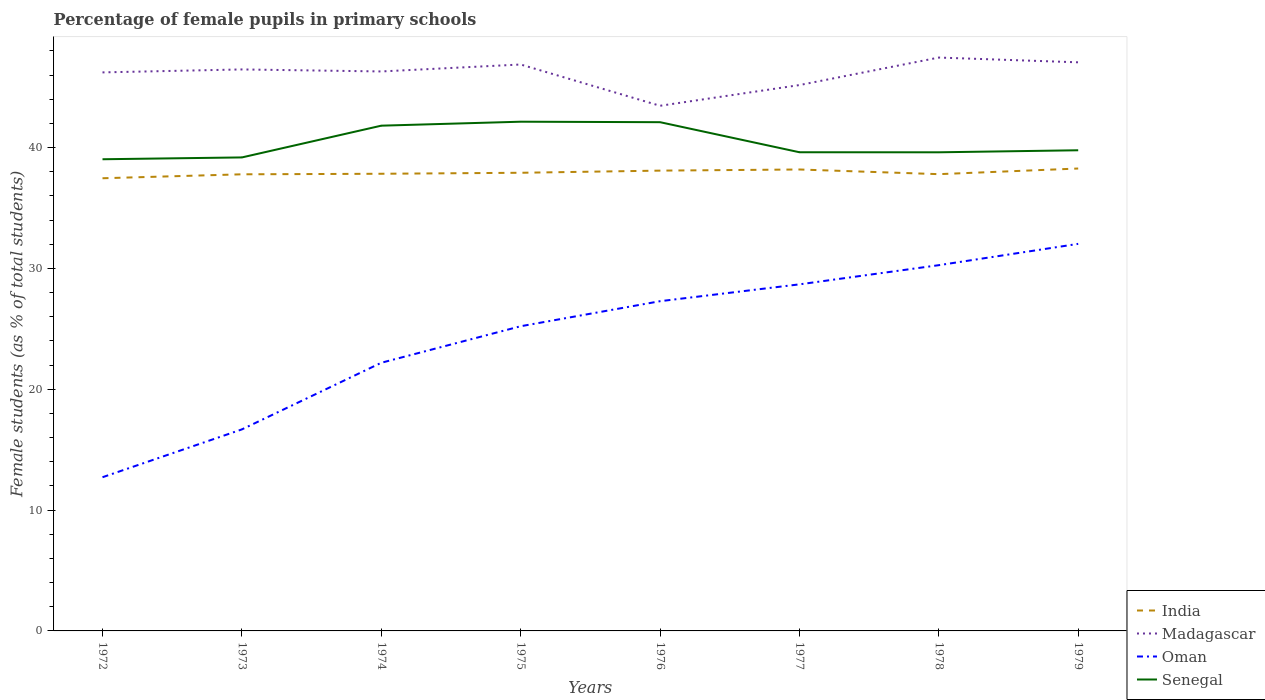Does the line corresponding to India intersect with the line corresponding to Oman?
Your answer should be compact. No. Is the number of lines equal to the number of legend labels?
Ensure brevity in your answer.  Yes. Across all years, what is the maximum percentage of female pupils in primary schools in Madagascar?
Give a very brief answer. 43.46. In which year was the percentage of female pupils in primary schools in Madagascar maximum?
Make the answer very short. 1976. What is the total percentage of female pupils in primary schools in Oman in the graph?
Your answer should be very brief. -2.07. What is the difference between the highest and the second highest percentage of female pupils in primary schools in Senegal?
Offer a terse response. 3.11. What is the difference between two consecutive major ticks on the Y-axis?
Give a very brief answer. 10. Are the values on the major ticks of Y-axis written in scientific E-notation?
Keep it short and to the point. No. Does the graph contain any zero values?
Your response must be concise. No. Where does the legend appear in the graph?
Provide a succinct answer. Bottom right. How many legend labels are there?
Make the answer very short. 4. What is the title of the graph?
Your answer should be compact. Percentage of female pupils in primary schools. What is the label or title of the Y-axis?
Offer a very short reply. Female students (as % of total students). What is the Female students (as % of total students) of India in 1972?
Offer a terse response. 37.46. What is the Female students (as % of total students) in Madagascar in 1972?
Offer a very short reply. 46.22. What is the Female students (as % of total students) in Oman in 1972?
Ensure brevity in your answer.  12.72. What is the Female students (as % of total students) in Senegal in 1972?
Keep it short and to the point. 39.03. What is the Female students (as % of total students) of India in 1973?
Offer a terse response. 37.79. What is the Female students (as % of total students) in Madagascar in 1973?
Ensure brevity in your answer.  46.47. What is the Female students (as % of total students) of Oman in 1973?
Provide a succinct answer. 16.68. What is the Female students (as % of total students) in Senegal in 1973?
Keep it short and to the point. 39.18. What is the Female students (as % of total students) of India in 1974?
Make the answer very short. 37.83. What is the Female students (as % of total students) in Madagascar in 1974?
Ensure brevity in your answer.  46.3. What is the Female students (as % of total students) of Oman in 1974?
Your answer should be very brief. 22.19. What is the Female students (as % of total students) of Senegal in 1974?
Your response must be concise. 41.81. What is the Female students (as % of total students) in India in 1975?
Your answer should be compact. 37.91. What is the Female students (as % of total students) in Madagascar in 1975?
Your answer should be compact. 46.87. What is the Female students (as % of total students) of Oman in 1975?
Provide a short and direct response. 25.21. What is the Female students (as % of total students) of Senegal in 1975?
Provide a succinct answer. 42.14. What is the Female students (as % of total students) in India in 1976?
Your response must be concise. 38.09. What is the Female students (as % of total students) in Madagascar in 1976?
Give a very brief answer. 43.46. What is the Female students (as % of total students) in Oman in 1976?
Your answer should be compact. 27.29. What is the Female students (as % of total students) in Senegal in 1976?
Your answer should be very brief. 42.1. What is the Female students (as % of total students) of India in 1977?
Provide a short and direct response. 38.18. What is the Female students (as % of total students) of Madagascar in 1977?
Provide a short and direct response. 45.17. What is the Female students (as % of total students) in Oman in 1977?
Keep it short and to the point. 28.68. What is the Female students (as % of total students) of Senegal in 1977?
Provide a succinct answer. 39.61. What is the Female students (as % of total students) of India in 1978?
Offer a very short reply. 37.8. What is the Female students (as % of total students) in Madagascar in 1978?
Offer a terse response. 47.45. What is the Female students (as % of total students) of Oman in 1978?
Ensure brevity in your answer.  30.27. What is the Female students (as % of total students) in Senegal in 1978?
Ensure brevity in your answer.  39.61. What is the Female students (as % of total students) in India in 1979?
Provide a succinct answer. 38.27. What is the Female students (as % of total students) in Madagascar in 1979?
Provide a succinct answer. 47.05. What is the Female students (as % of total students) in Oman in 1979?
Your answer should be compact. 32.03. What is the Female students (as % of total students) of Senegal in 1979?
Make the answer very short. 39.78. Across all years, what is the maximum Female students (as % of total students) in India?
Ensure brevity in your answer.  38.27. Across all years, what is the maximum Female students (as % of total students) of Madagascar?
Ensure brevity in your answer.  47.45. Across all years, what is the maximum Female students (as % of total students) in Oman?
Give a very brief answer. 32.03. Across all years, what is the maximum Female students (as % of total students) of Senegal?
Ensure brevity in your answer.  42.14. Across all years, what is the minimum Female students (as % of total students) of India?
Make the answer very short. 37.46. Across all years, what is the minimum Female students (as % of total students) of Madagascar?
Keep it short and to the point. 43.46. Across all years, what is the minimum Female students (as % of total students) of Oman?
Provide a succinct answer. 12.72. Across all years, what is the minimum Female students (as % of total students) of Senegal?
Give a very brief answer. 39.03. What is the total Female students (as % of total students) in India in the graph?
Make the answer very short. 303.33. What is the total Female students (as % of total students) in Madagascar in the graph?
Your answer should be very brief. 368.99. What is the total Female students (as % of total students) in Oman in the graph?
Offer a terse response. 195.06. What is the total Female students (as % of total students) in Senegal in the graph?
Your response must be concise. 323.26. What is the difference between the Female students (as % of total students) in India in 1972 and that in 1973?
Keep it short and to the point. -0.33. What is the difference between the Female students (as % of total students) of Madagascar in 1972 and that in 1973?
Your answer should be compact. -0.24. What is the difference between the Female students (as % of total students) in Oman in 1972 and that in 1973?
Provide a succinct answer. -3.96. What is the difference between the Female students (as % of total students) in Senegal in 1972 and that in 1973?
Your response must be concise. -0.15. What is the difference between the Female students (as % of total students) of India in 1972 and that in 1974?
Ensure brevity in your answer.  -0.37. What is the difference between the Female students (as % of total students) of Madagascar in 1972 and that in 1974?
Provide a succinct answer. -0.08. What is the difference between the Female students (as % of total students) of Oman in 1972 and that in 1974?
Offer a terse response. -9.47. What is the difference between the Female students (as % of total students) in Senegal in 1972 and that in 1974?
Keep it short and to the point. -2.78. What is the difference between the Female students (as % of total students) in India in 1972 and that in 1975?
Keep it short and to the point. -0.45. What is the difference between the Female students (as % of total students) of Madagascar in 1972 and that in 1975?
Offer a very short reply. -0.65. What is the difference between the Female students (as % of total students) of Oman in 1972 and that in 1975?
Make the answer very short. -12.49. What is the difference between the Female students (as % of total students) of Senegal in 1972 and that in 1975?
Offer a terse response. -3.11. What is the difference between the Female students (as % of total students) in India in 1972 and that in 1976?
Make the answer very short. -0.63. What is the difference between the Female students (as % of total students) in Madagascar in 1972 and that in 1976?
Provide a succinct answer. 2.76. What is the difference between the Female students (as % of total students) of Oman in 1972 and that in 1976?
Provide a succinct answer. -14.57. What is the difference between the Female students (as % of total students) of Senegal in 1972 and that in 1976?
Provide a short and direct response. -3.07. What is the difference between the Female students (as % of total students) in India in 1972 and that in 1977?
Your answer should be compact. -0.72. What is the difference between the Female students (as % of total students) in Madagascar in 1972 and that in 1977?
Ensure brevity in your answer.  1.05. What is the difference between the Female students (as % of total students) of Oman in 1972 and that in 1977?
Offer a terse response. -15.96. What is the difference between the Female students (as % of total students) in Senegal in 1972 and that in 1977?
Make the answer very short. -0.58. What is the difference between the Female students (as % of total students) in India in 1972 and that in 1978?
Give a very brief answer. -0.34. What is the difference between the Female students (as % of total students) in Madagascar in 1972 and that in 1978?
Make the answer very short. -1.23. What is the difference between the Female students (as % of total students) in Oman in 1972 and that in 1978?
Provide a succinct answer. -17.55. What is the difference between the Female students (as % of total students) in Senegal in 1972 and that in 1978?
Ensure brevity in your answer.  -0.58. What is the difference between the Female students (as % of total students) in India in 1972 and that in 1979?
Your answer should be compact. -0.81. What is the difference between the Female students (as % of total students) of Madagascar in 1972 and that in 1979?
Provide a succinct answer. -0.83. What is the difference between the Female students (as % of total students) of Oman in 1972 and that in 1979?
Your response must be concise. -19.31. What is the difference between the Female students (as % of total students) of Senegal in 1972 and that in 1979?
Give a very brief answer. -0.74. What is the difference between the Female students (as % of total students) of India in 1973 and that in 1974?
Make the answer very short. -0.04. What is the difference between the Female students (as % of total students) in Madagascar in 1973 and that in 1974?
Give a very brief answer. 0.17. What is the difference between the Female students (as % of total students) of Oman in 1973 and that in 1974?
Provide a succinct answer. -5.51. What is the difference between the Female students (as % of total students) in Senegal in 1973 and that in 1974?
Your answer should be compact. -2.63. What is the difference between the Female students (as % of total students) in India in 1973 and that in 1975?
Offer a terse response. -0.13. What is the difference between the Female students (as % of total students) in Madagascar in 1973 and that in 1975?
Keep it short and to the point. -0.41. What is the difference between the Female students (as % of total students) of Oman in 1973 and that in 1975?
Make the answer very short. -8.54. What is the difference between the Female students (as % of total students) in Senegal in 1973 and that in 1975?
Offer a terse response. -2.96. What is the difference between the Female students (as % of total students) in India in 1973 and that in 1976?
Make the answer very short. -0.31. What is the difference between the Female students (as % of total students) in Madagascar in 1973 and that in 1976?
Keep it short and to the point. 3.01. What is the difference between the Female students (as % of total students) in Oman in 1973 and that in 1976?
Offer a terse response. -10.61. What is the difference between the Female students (as % of total students) of Senegal in 1973 and that in 1976?
Provide a short and direct response. -2.92. What is the difference between the Female students (as % of total students) in India in 1973 and that in 1977?
Offer a very short reply. -0.4. What is the difference between the Female students (as % of total students) in Madagascar in 1973 and that in 1977?
Provide a succinct answer. 1.29. What is the difference between the Female students (as % of total students) of Oman in 1973 and that in 1977?
Your answer should be compact. -12. What is the difference between the Female students (as % of total students) in Senegal in 1973 and that in 1977?
Your answer should be very brief. -0.43. What is the difference between the Female students (as % of total students) of India in 1973 and that in 1978?
Offer a very short reply. -0.01. What is the difference between the Female students (as % of total students) in Madagascar in 1973 and that in 1978?
Your response must be concise. -0.98. What is the difference between the Female students (as % of total students) in Oman in 1973 and that in 1978?
Offer a terse response. -13.59. What is the difference between the Female students (as % of total students) of Senegal in 1973 and that in 1978?
Give a very brief answer. -0.42. What is the difference between the Female students (as % of total students) in India in 1973 and that in 1979?
Provide a short and direct response. -0.48. What is the difference between the Female students (as % of total students) of Madagascar in 1973 and that in 1979?
Your response must be concise. -0.59. What is the difference between the Female students (as % of total students) in Oman in 1973 and that in 1979?
Offer a terse response. -15.35. What is the difference between the Female students (as % of total students) in Senegal in 1973 and that in 1979?
Provide a short and direct response. -0.59. What is the difference between the Female students (as % of total students) of India in 1974 and that in 1975?
Offer a terse response. -0.08. What is the difference between the Female students (as % of total students) in Madagascar in 1974 and that in 1975?
Give a very brief answer. -0.58. What is the difference between the Female students (as % of total students) of Oman in 1974 and that in 1975?
Give a very brief answer. -3.02. What is the difference between the Female students (as % of total students) in Senegal in 1974 and that in 1975?
Offer a very short reply. -0.33. What is the difference between the Female students (as % of total students) of India in 1974 and that in 1976?
Give a very brief answer. -0.26. What is the difference between the Female students (as % of total students) of Madagascar in 1974 and that in 1976?
Your answer should be very brief. 2.84. What is the difference between the Female students (as % of total students) of Oman in 1974 and that in 1976?
Keep it short and to the point. -5.1. What is the difference between the Female students (as % of total students) in Senegal in 1974 and that in 1976?
Provide a succinct answer. -0.29. What is the difference between the Female students (as % of total students) of India in 1974 and that in 1977?
Your answer should be compact. -0.35. What is the difference between the Female students (as % of total students) of Madagascar in 1974 and that in 1977?
Make the answer very short. 1.13. What is the difference between the Female students (as % of total students) in Oman in 1974 and that in 1977?
Keep it short and to the point. -6.49. What is the difference between the Female students (as % of total students) in Senegal in 1974 and that in 1977?
Offer a very short reply. 2.2. What is the difference between the Female students (as % of total students) of India in 1974 and that in 1978?
Your answer should be compact. 0.03. What is the difference between the Female students (as % of total students) in Madagascar in 1974 and that in 1978?
Provide a short and direct response. -1.15. What is the difference between the Female students (as % of total students) in Oman in 1974 and that in 1978?
Keep it short and to the point. -8.08. What is the difference between the Female students (as % of total students) of Senegal in 1974 and that in 1978?
Provide a succinct answer. 2.2. What is the difference between the Female students (as % of total students) in India in 1974 and that in 1979?
Make the answer very short. -0.43. What is the difference between the Female students (as % of total students) in Madagascar in 1974 and that in 1979?
Offer a terse response. -0.76. What is the difference between the Female students (as % of total students) of Oman in 1974 and that in 1979?
Provide a short and direct response. -9.84. What is the difference between the Female students (as % of total students) in Senegal in 1974 and that in 1979?
Provide a succinct answer. 2.03. What is the difference between the Female students (as % of total students) of India in 1975 and that in 1976?
Your answer should be compact. -0.18. What is the difference between the Female students (as % of total students) in Madagascar in 1975 and that in 1976?
Offer a terse response. 3.42. What is the difference between the Female students (as % of total students) in Oman in 1975 and that in 1976?
Your answer should be very brief. -2.07. What is the difference between the Female students (as % of total students) in Senegal in 1975 and that in 1976?
Offer a very short reply. 0.04. What is the difference between the Female students (as % of total students) in India in 1975 and that in 1977?
Make the answer very short. -0.27. What is the difference between the Female students (as % of total students) in Madagascar in 1975 and that in 1977?
Keep it short and to the point. 1.7. What is the difference between the Female students (as % of total students) of Oman in 1975 and that in 1977?
Make the answer very short. -3.47. What is the difference between the Female students (as % of total students) in Senegal in 1975 and that in 1977?
Provide a short and direct response. 2.53. What is the difference between the Female students (as % of total students) of India in 1975 and that in 1978?
Give a very brief answer. 0.11. What is the difference between the Female students (as % of total students) of Madagascar in 1975 and that in 1978?
Keep it short and to the point. -0.57. What is the difference between the Female students (as % of total students) of Oman in 1975 and that in 1978?
Provide a succinct answer. -5.05. What is the difference between the Female students (as % of total students) in Senegal in 1975 and that in 1978?
Offer a terse response. 2.53. What is the difference between the Female students (as % of total students) in India in 1975 and that in 1979?
Ensure brevity in your answer.  -0.35. What is the difference between the Female students (as % of total students) of Madagascar in 1975 and that in 1979?
Ensure brevity in your answer.  -0.18. What is the difference between the Female students (as % of total students) in Oman in 1975 and that in 1979?
Give a very brief answer. -6.82. What is the difference between the Female students (as % of total students) in Senegal in 1975 and that in 1979?
Ensure brevity in your answer.  2.36. What is the difference between the Female students (as % of total students) in India in 1976 and that in 1977?
Offer a very short reply. -0.09. What is the difference between the Female students (as % of total students) in Madagascar in 1976 and that in 1977?
Give a very brief answer. -1.71. What is the difference between the Female students (as % of total students) in Oman in 1976 and that in 1977?
Offer a very short reply. -1.39. What is the difference between the Female students (as % of total students) in Senegal in 1976 and that in 1977?
Your answer should be very brief. 2.49. What is the difference between the Female students (as % of total students) in India in 1976 and that in 1978?
Give a very brief answer. 0.29. What is the difference between the Female students (as % of total students) in Madagascar in 1976 and that in 1978?
Provide a short and direct response. -3.99. What is the difference between the Female students (as % of total students) in Oman in 1976 and that in 1978?
Make the answer very short. -2.98. What is the difference between the Female students (as % of total students) in Senegal in 1976 and that in 1978?
Ensure brevity in your answer.  2.49. What is the difference between the Female students (as % of total students) of India in 1976 and that in 1979?
Ensure brevity in your answer.  -0.17. What is the difference between the Female students (as % of total students) of Madagascar in 1976 and that in 1979?
Your answer should be compact. -3.6. What is the difference between the Female students (as % of total students) of Oman in 1976 and that in 1979?
Your response must be concise. -4.74. What is the difference between the Female students (as % of total students) of Senegal in 1976 and that in 1979?
Your answer should be very brief. 2.32. What is the difference between the Female students (as % of total students) in India in 1977 and that in 1978?
Your answer should be compact. 0.39. What is the difference between the Female students (as % of total students) of Madagascar in 1977 and that in 1978?
Your answer should be compact. -2.28. What is the difference between the Female students (as % of total students) in Oman in 1977 and that in 1978?
Offer a terse response. -1.59. What is the difference between the Female students (as % of total students) in Senegal in 1977 and that in 1978?
Your response must be concise. 0. What is the difference between the Female students (as % of total students) in India in 1977 and that in 1979?
Ensure brevity in your answer.  -0.08. What is the difference between the Female students (as % of total students) in Madagascar in 1977 and that in 1979?
Provide a succinct answer. -1.88. What is the difference between the Female students (as % of total students) of Oman in 1977 and that in 1979?
Ensure brevity in your answer.  -3.35. What is the difference between the Female students (as % of total students) in Senegal in 1977 and that in 1979?
Provide a succinct answer. -0.16. What is the difference between the Female students (as % of total students) in India in 1978 and that in 1979?
Your response must be concise. -0.47. What is the difference between the Female students (as % of total students) in Madagascar in 1978 and that in 1979?
Provide a succinct answer. 0.39. What is the difference between the Female students (as % of total students) in Oman in 1978 and that in 1979?
Offer a very short reply. -1.76. What is the difference between the Female students (as % of total students) of Senegal in 1978 and that in 1979?
Offer a very short reply. -0.17. What is the difference between the Female students (as % of total students) in India in 1972 and the Female students (as % of total students) in Madagascar in 1973?
Your answer should be compact. -9. What is the difference between the Female students (as % of total students) of India in 1972 and the Female students (as % of total students) of Oman in 1973?
Give a very brief answer. 20.78. What is the difference between the Female students (as % of total students) of India in 1972 and the Female students (as % of total students) of Senegal in 1973?
Your answer should be very brief. -1.72. What is the difference between the Female students (as % of total students) of Madagascar in 1972 and the Female students (as % of total students) of Oman in 1973?
Provide a succinct answer. 29.54. What is the difference between the Female students (as % of total students) in Madagascar in 1972 and the Female students (as % of total students) in Senegal in 1973?
Make the answer very short. 7.04. What is the difference between the Female students (as % of total students) in Oman in 1972 and the Female students (as % of total students) in Senegal in 1973?
Keep it short and to the point. -26.46. What is the difference between the Female students (as % of total students) of India in 1972 and the Female students (as % of total students) of Madagascar in 1974?
Your response must be concise. -8.84. What is the difference between the Female students (as % of total students) of India in 1972 and the Female students (as % of total students) of Oman in 1974?
Ensure brevity in your answer.  15.27. What is the difference between the Female students (as % of total students) in India in 1972 and the Female students (as % of total students) in Senegal in 1974?
Give a very brief answer. -4.35. What is the difference between the Female students (as % of total students) of Madagascar in 1972 and the Female students (as % of total students) of Oman in 1974?
Provide a short and direct response. 24.03. What is the difference between the Female students (as % of total students) of Madagascar in 1972 and the Female students (as % of total students) of Senegal in 1974?
Make the answer very short. 4.41. What is the difference between the Female students (as % of total students) of Oman in 1972 and the Female students (as % of total students) of Senegal in 1974?
Your response must be concise. -29.09. What is the difference between the Female students (as % of total students) of India in 1972 and the Female students (as % of total students) of Madagascar in 1975?
Provide a succinct answer. -9.41. What is the difference between the Female students (as % of total students) in India in 1972 and the Female students (as % of total students) in Oman in 1975?
Provide a short and direct response. 12.25. What is the difference between the Female students (as % of total students) of India in 1972 and the Female students (as % of total students) of Senegal in 1975?
Keep it short and to the point. -4.68. What is the difference between the Female students (as % of total students) of Madagascar in 1972 and the Female students (as % of total students) of Oman in 1975?
Make the answer very short. 21.01. What is the difference between the Female students (as % of total students) of Madagascar in 1972 and the Female students (as % of total students) of Senegal in 1975?
Make the answer very short. 4.08. What is the difference between the Female students (as % of total students) of Oman in 1972 and the Female students (as % of total students) of Senegal in 1975?
Offer a very short reply. -29.42. What is the difference between the Female students (as % of total students) of India in 1972 and the Female students (as % of total students) of Madagascar in 1976?
Ensure brevity in your answer.  -6. What is the difference between the Female students (as % of total students) of India in 1972 and the Female students (as % of total students) of Oman in 1976?
Give a very brief answer. 10.17. What is the difference between the Female students (as % of total students) of India in 1972 and the Female students (as % of total students) of Senegal in 1976?
Ensure brevity in your answer.  -4.64. What is the difference between the Female students (as % of total students) of Madagascar in 1972 and the Female students (as % of total students) of Oman in 1976?
Provide a short and direct response. 18.94. What is the difference between the Female students (as % of total students) of Madagascar in 1972 and the Female students (as % of total students) of Senegal in 1976?
Provide a short and direct response. 4.12. What is the difference between the Female students (as % of total students) of Oman in 1972 and the Female students (as % of total students) of Senegal in 1976?
Make the answer very short. -29.38. What is the difference between the Female students (as % of total students) in India in 1972 and the Female students (as % of total students) in Madagascar in 1977?
Your response must be concise. -7.71. What is the difference between the Female students (as % of total students) in India in 1972 and the Female students (as % of total students) in Oman in 1977?
Provide a succinct answer. 8.78. What is the difference between the Female students (as % of total students) of India in 1972 and the Female students (as % of total students) of Senegal in 1977?
Provide a succinct answer. -2.15. What is the difference between the Female students (as % of total students) of Madagascar in 1972 and the Female students (as % of total students) of Oman in 1977?
Offer a terse response. 17.54. What is the difference between the Female students (as % of total students) of Madagascar in 1972 and the Female students (as % of total students) of Senegal in 1977?
Keep it short and to the point. 6.61. What is the difference between the Female students (as % of total students) of Oman in 1972 and the Female students (as % of total students) of Senegal in 1977?
Your answer should be very brief. -26.89. What is the difference between the Female students (as % of total students) in India in 1972 and the Female students (as % of total students) in Madagascar in 1978?
Provide a succinct answer. -9.99. What is the difference between the Female students (as % of total students) of India in 1972 and the Female students (as % of total students) of Oman in 1978?
Ensure brevity in your answer.  7.19. What is the difference between the Female students (as % of total students) of India in 1972 and the Female students (as % of total students) of Senegal in 1978?
Provide a succinct answer. -2.15. What is the difference between the Female students (as % of total students) of Madagascar in 1972 and the Female students (as % of total students) of Oman in 1978?
Ensure brevity in your answer.  15.95. What is the difference between the Female students (as % of total students) in Madagascar in 1972 and the Female students (as % of total students) in Senegal in 1978?
Ensure brevity in your answer.  6.61. What is the difference between the Female students (as % of total students) in Oman in 1972 and the Female students (as % of total students) in Senegal in 1978?
Provide a succinct answer. -26.89. What is the difference between the Female students (as % of total students) of India in 1972 and the Female students (as % of total students) of Madagascar in 1979?
Your response must be concise. -9.59. What is the difference between the Female students (as % of total students) in India in 1972 and the Female students (as % of total students) in Oman in 1979?
Offer a terse response. 5.43. What is the difference between the Female students (as % of total students) of India in 1972 and the Female students (as % of total students) of Senegal in 1979?
Offer a terse response. -2.32. What is the difference between the Female students (as % of total students) in Madagascar in 1972 and the Female students (as % of total students) in Oman in 1979?
Make the answer very short. 14.19. What is the difference between the Female students (as % of total students) in Madagascar in 1972 and the Female students (as % of total students) in Senegal in 1979?
Your answer should be compact. 6.44. What is the difference between the Female students (as % of total students) in Oman in 1972 and the Female students (as % of total students) in Senegal in 1979?
Ensure brevity in your answer.  -27.06. What is the difference between the Female students (as % of total students) in India in 1973 and the Female students (as % of total students) in Madagascar in 1974?
Keep it short and to the point. -8.51. What is the difference between the Female students (as % of total students) in India in 1973 and the Female students (as % of total students) in Oman in 1974?
Your answer should be very brief. 15.6. What is the difference between the Female students (as % of total students) of India in 1973 and the Female students (as % of total students) of Senegal in 1974?
Your answer should be compact. -4.02. What is the difference between the Female students (as % of total students) in Madagascar in 1973 and the Female students (as % of total students) in Oman in 1974?
Offer a very short reply. 24.27. What is the difference between the Female students (as % of total students) in Madagascar in 1973 and the Female students (as % of total students) in Senegal in 1974?
Give a very brief answer. 4.65. What is the difference between the Female students (as % of total students) in Oman in 1973 and the Female students (as % of total students) in Senegal in 1974?
Ensure brevity in your answer.  -25.13. What is the difference between the Female students (as % of total students) of India in 1973 and the Female students (as % of total students) of Madagascar in 1975?
Ensure brevity in your answer.  -9.09. What is the difference between the Female students (as % of total students) of India in 1973 and the Female students (as % of total students) of Oman in 1975?
Your answer should be compact. 12.57. What is the difference between the Female students (as % of total students) in India in 1973 and the Female students (as % of total students) in Senegal in 1975?
Your answer should be very brief. -4.35. What is the difference between the Female students (as % of total students) in Madagascar in 1973 and the Female students (as % of total students) in Oman in 1975?
Make the answer very short. 21.25. What is the difference between the Female students (as % of total students) in Madagascar in 1973 and the Female students (as % of total students) in Senegal in 1975?
Ensure brevity in your answer.  4.33. What is the difference between the Female students (as % of total students) in Oman in 1973 and the Female students (as % of total students) in Senegal in 1975?
Make the answer very short. -25.46. What is the difference between the Female students (as % of total students) in India in 1973 and the Female students (as % of total students) in Madagascar in 1976?
Make the answer very short. -5.67. What is the difference between the Female students (as % of total students) of India in 1973 and the Female students (as % of total students) of Oman in 1976?
Your response must be concise. 10.5. What is the difference between the Female students (as % of total students) in India in 1973 and the Female students (as % of total students) in Senegal in 1976?
Make the answer very short. -4.31. What is the difference between the Female students (as % of total students) in Madagascar in 1973 and the Female students (as % of total students) in Oman in 1976?
Keep it short and to the point. 19.18. What is the difference between the Female students (as % of total students) of Madagascar in 1973 and the Female students (as % of total students) of Senegal in 1976?
Give a very brief answer. 4.37. What is the difference between the Female students (as % of total students) in Oman in 1973 and the Female students (as % of total students) in Senegal in 1976?
Offer a terse response. -25.42. What is the difference between the Female students (as % of total students) of India in 1973 and the Female students (as % of total students) of Madagascar in 1977?
Keep it short and to the point. -7.38. What is the difference between the Female students (as % of total students) of India in 1973 and the Female students (as % of total students) of Oman in 1977?
Offer a very short reply. 9.11. What is the difference between the Female students (as % of total students) of India in 1973 and the Female students (as % of total students) of Senegal in 1977?
Ensure brevity in your answer.  -1.83. What is the difference between the Female students (as % of total students) in Madagascar in 1973 and the Female students (as % of total students) in Oman in 1977?
Provide a short and direct response. 17.79. What is the difference between the Female students (as % of total students) in Madagascar in 1973 and the Female students (as % of total students) in Senegal in 1977?
Provide a succinct answer. 6.85. What is the difference between the Female students (as % of total students) of Oman in 1973 and the Female students (as % of total students) of Senegal in 1977?
Offer a terse response. -22.94. What is the difference between the Female students (as % of total students) in India in 1973 and the Female students (as % of total students) in Madagascar in 1978?
Provide a succinct answer. -9.66. What is the difference between the Female students (as % of total students) in India in 1973 and the Female students (as % of total students) in Oman in 1978?
Your answer should be very brief. 7.52. What is the difference between the Female students (as % of total students) of India in 1973 and the Female students (as % of total students) of Senegal in 1978?
Ensure brevity in your answer.  -1.82. What is the difference between the Female students (as % of total students) of Madagascar in 1973 and the Female students (as % of total students) of Oman in 1978?
Give a very brief answer. 16.2. What is the difference between the Female students (as % of total students) in Madagascar in 1973 and the Female students (as % of total students) in Senegal in 1978?
Your response must be concise. 6.86. What is the difference between the Female students (as % of total students) of Oman in 1973 and the Female students (as % of total students) of Senegal in 1978?
Provide a succinct answer. -22.93. What is the difference between the Female students (as % of total students) of India in 1973 and the Female students (as % of total students) of Madagascar in 1979?
Provide a short and direct response. -9.27. What is the difference between the Female students (as % of total students) in India in 1973 and the Female students (as % of total students) in Oman in 1979?
Your response must be concise. 5.76. What is the difference between the Female students (as % of total students) of India in 1973 and the Female students (as % of total students) of Senegal in 1979?
Offer a very short reply. -1.99. What is the difference between the Female students (as % of total students) in Madagascar in 1973 and the Female students (as % of total students) in Oman in 1979?
Ensure brevity in your answer.  14.44. What is the difference between the Female students (as % of total students) of Madagascar in 1973 and the Female students (as % of total students) of Senegal in 1979?
Make the answer very short. 6.69. What is the difference between the Female students (as % of total students) in Oman in 1973 and the Female students (as % of total students) in Senegal in 1979?
Give a very brief answer. -23.1. What is the difference between the Female students (as % of total students) of India in 1974 and the Female students (as % of total students) of Madagascar in 1975?
Give a very brief answer. -9.04. What is the difference between the Female students (as % of total students) of India in 1974 and the Female students (as % of total students) of Oman in 1975?
Provide a succinct answer. 12.62. What is the difference between the Female students (as % of total students) of India in 1974 and the Female students (as % of total students) of Senegal in 1975?
Give a very brief answer. -4.31. What is the difference between the Female students (as % of total students) in Madagascar in 1974 and the Female students (as % of total students) in Oman in 1975?
Offer a very short reply. 21.08. What is the difference between the Female students (as % of total students) in Madagascar in 1974 and the Female students (as % of total students) in Senegal in 1975?
Provide a succinct answer. 4.16. What is the difference between the Female students (as % of total students) in Oman in 1974 and the Female students (as % of total students) in Senegal in 1975?
Give a very brief answer. -19.95. What is the difference between the Female students (as % of total students) of India in 1974 and the Female students (as % of total students) of Madagascar in 1976?
Give a very brief answer. -5.63. What is the difference between the Female students (as % of total students) of India in 1974 and the Female students (as % of total students) of Oman in 1976?
Provide a succinct answer. 10.55. What is the difference between the Female students (as % of total students) of India in 1974 and the Female students (as % of total students) of Senegal in 1976?
Provide a succinct answer. -4.27. What is the difference between the Female students (as % of total students) in Madagascar in 1974 and the Female students (as % of total students) in Oman in 1976?
Provide a succinct answer. 19.01. What is the difference between the Female students (as % of total students) in Madagascar in 1974 and the Female students (as % of total students) in Senegal in 1976?
Make the answer very short. 4.2. What is the difference between the Female students (as % of total students) of Oman in 1974 and the Female students (as % of total students) of Senegal in 1976?
Ensure brevity in your answer.  -19.91. What is the difference between the Female students (as % of total students) of India in 1974 and the Female students (as % of total students) of Madagascar in 1977?
Offer a terse response. -7.34. What is the difference between the Female students (as % of total students) in India in 1974 and the Female students (as % of total students) in Oman in 1977?
Keep it short and to the point. 9.15. What is the difference between the Female students (as % of total students) in India in 1974 and the Female students (as % of total students) in Senegal in 1977?
Ensure brevity in your answer.  -1.78. What is the difference between the Female students (as % of total students) in Madagascar in 1974 and the Female students (as % of total students) in Oman in 1977?
Your answer should be compact. 17.62. What is the difference between the Female students (as % of total students) of Madagascar in 1974 and the Female students (as % of total students) of Senegal in 1977?
Your response must be concise. 6.69. What is the difference between the Female students (as % of total students) of Oman in 1974 and the Female students (as % of total students) of Senegal in 1977?
Ensure brevity in your answer.  -17.42. What is the difference between the Female students (as % of total students) of India in 1974 and the Female students (as % of total students) of Madagascar in 1978?
Ensure brevity in your answer.  -9.62. What is the difference between the Female students (as % of total students) of India in 1974 and the Female students (as % of total students) of Oman in 1978?
Your response must be concise. 7.56. What is the difference between the Female students (as % of total students) in India in 1974 and the Female students (as % of total students) in Senegal in 1978?
Ensure brevity in your answer.  -1.78. What is the difference between the Female students (as % of total students) in Madagascar in 1974 and the Female students (as % of total students) in Oman in 1978?
Offer a terse response. 16.03. What is the difference between the Female students (as % of total students) of Madagascar in 1974 and the Female students (as % of total students) of Senegal in 1978?
Provide a short and direct response. 6.69. What is the difference between the Female students (as % of total students) of Oman in 1974 and the Female students (as % of total students) of Senegal in 1978?
Ensure brevity in your answer.  -17.42. What is the difference between the Female students (as % of total students) of India in 1974 and the Female students (as % of total students) of Madagascar in 1979?
Ensure brevity in your answer.  -9.22. What is the difference between the Female students (as % of total students) of India in 1974 and the Female students (as % of total students) of Oman in 1979?
Keep it short and to the point. 5.8. What is the difference between the Female students (as % of total students) of India in 1974 and the Female students (as % of total students) of Senegal in 1979?
Offer a very short reply. -1.95. What is the difference between the Female students (as % of total students) of Madagascar in 1974 and the Female students (as % of total students) of Oman in 1979?
Offer a very short reply. 14.27. What is the difference between the Female students (as % of total students) of Madagascar in 1974 and the Female students (as % of total students) of Senegal in 1979?
Make the answer very short. 6.52. What is the difference between the Female students (as % of total students) of Oman in 1974 and the Female students (as % of total students) of Senegal in 1979?
Your answer should be very brief. -17.59. What is the difference between the Female students (as % of total students) in India in 1975 and the Female students (as % of total students) in Madagascar in 1976?
Provide a succinct answer. -5.54. What is the difference between the Female students (as % of total students) of India in 1975 and the Female students (as % of total students) of Oman in 1976?
Ensure brevity in your answer.  10.63. What is the difference between the Female students (as % of total students) of India in 1975 and the Female students (as % of total students) of Senegal in 1976?
Your answer should be compact. -4.19. What is the difference between the Female students (as % of total students) in Madagascar in 1975 and the Female students (as % of total students) in Oman in 1976?
Your answer should be very brief. 19.59. What is the difference between the Female students (as % of total students) of Madagascar in 1975 and the Female students (as % of total students) of Senegal in 1976?
Your answer should be very brief. 4.77. What is the difference between the Female students (as % of total students) of Oman in 1975 and the Female students (as % of total students) of Senegal in 1976?
Offer a very short reply. -16.89. What is the difference between the Female students (as % of total students) in India in 1975 and the Female students (as % of total students) in Madagascar in 1977?
Ensure brevity in your answer.  -7.26. What is the difference between the Female students (as % of total students) of India in 1975 and the Female students (as % of total students) of Oman in 1977?
Provide a short and direct response. 9.23. What is the difference between the Female students (as % of total students) in India in 1975 and the Female students (as % of total students) in Senegal in 1977?
Keep it short and to the point. -1.7. What is the difference between the Female students (as % of total students) in Madagascar in 1975 and the Female students (as % of total students) in Oman in 1977?
Offer a very short reply. 18.19. What is the difference between the Female students (as % of total students) of Madagascar in 1975 and the Female students (as % of total students) of Senegal in 1977?
Your answer should be very brief. 7.26. What is the difference between the Female students (as % of total students) in Oman in 1975 and the Female students (as % of total students) in Senegal in 1977?
Your response must be concise. -14.4. What is the difference between the Female students (as % of total students) in India in 1975 and the Female students (as % of total students) in Madagascar in 1978?
Your response must be concise. -9.53. What is the difference between the Female students (as % of total students) of India in 1975 and the Female students (as % of total students) of Oman in 1978?
Offer a terse response. 7.65. What is the difference between the Female students (as % of total students) of India in 1975 and the Female students (as % of total students) of Senegal in 1978?
Provide a succinct answer. -1.69. What is the difference between the Female students (as % of total students) in Madagascar in 1975 and the Female students (as % of total students) in Oman in 1978?
Your response must be concise. 16.61. What is the difference between the Female students (as % of total students) in Madagascar in 1975 and the Female students (as % of total students) in Senegal in 1978?
Your response must be concise. 7.27. What is the difference between the Female students (as % of total students) of Oman in 1975 and the Female students (as % of total students) of Senegal in 1978?
Give a very brief answer. -14.39. What is the difference between the Female students (as % of total students) in India in 1975 and the Female students (as % of total students) in Madagascar in 1979?
Provide a succinct answer. -9.14. What is the difference between the Female students (as % of total students) of India in 1975 and the Female students (as % of total students) of Oman in 1979?
Offer a terse response. 5.88. What is the difference between the Female students (as % of total students) in India in 1975 and the Female students (as % of total students) in Senegal in 1979?
Your answer should be very brief. -1.86. What is the difference between the Female students (as % of total students) in Madagascar in 1975 and the Female students (as % of total students) in Oman in 1979?
Offer a terse response. 14.84. What is the difference between the Female students (as % of total students) of Madagascar in 1975 and the Female students (as % of total students) of Senegal in 1979?
Make the answer very short. 7.1. What is the difference between the Female students (as % of total students) in Oman in 1975 and the Female students (as % of total students) in Senegal in 1979?
Your answer should be very brief. -14.56. What is the difference between the Female students (as % of total students) in India in 1976 and the Female students (as % of total students) in Madagascar in 1977?
Offer a terse response. -7.08. What is the difference between the Female students (as % of total students) in India in 1976 and the Female students (as % of total students) in Oman in 1977?
Offer a terse response. 9.41. What is the difference between the Female students (as % of total students) in India in 1976 and the Female students (as % of total students) in Senegal in 1977?
Make the answer very short. -1.52. What is the difference between the Female students (as % of total students) in Madagascar in 1976 and the Female students (as % of total students) in Oman in 1977?
Your response must be concise. 14.78. What is the difference between the Female students (as % of total students) of Madagascar in 1976 and the Female students (as % of total students) of Senegal in 1977?
Keep it short and to the point. 3.85. What is the difference between the Female students (as % of total students) of Oman in 1976 and the Female students (as % of total students) of Senegal in 1977?
Keep it short and to the point. -12.33. What is the difference between the Female students (as % of total students) of India in 1976 and the Female students (as % of total students) of Madagascar in 1978?
Keep it short and to the point. -9.36. What is the difference between the Female students (as % of total students) of India in 1976 and the Female students (as % of total students) of Oman in 1978?
Keep it short and to the point. 7.82. What is the difference between the Female students (as % of total students) in India in 1976 and the Female students (as % of total students) in Senegal in 1978?
Keep it short and to the point. -1.52. What is the difference between the Female students (as % of total students) of Madagascar in 1976 and the Female students (as % of total students) of Oman in 1978?
Offer a terse response. 13.19. What is the difference between the Female students (as % of total students) in Madagascar in 1976 and the Female students (as % of total students) in Senegal in 1978?
Ensure brevity in your answer.  3.85. What is the difference between the Female students (as % of total students) in Oman in 1976 and the Female students (as % of total students) in Senegal in 1978?
Provide a short and direct response. -12.32. What is the difference between the Female students (as % of total students) of India in 1976 and the Female students (as % of total students) of Madagascar in 1979?
Your response must be concise. -8.96. What is the difference between the Female students (as % of total students) of India in 1976 and the Female students (as % of total students) of Oman in 1979?
Your response must be concise. 6.06. What is the difference between the Female students (as % of total students) in India in 1976 and the Female students (as % of total students) in Senegal in 1979?
Keep it short and to the point. -1.68. What is the difference between the Female students (as % of total students) of Madagascar in 1976 and the Female students (as % of total students) of Oman in 1979?
Provide a short and direct response. 11.43. What is the difference between the Female students (as % of total students) of Madagascar in 1976 and the Female students (as % of total students) of Senegal in 1979?
Provide a succinct answer. 3.68. What is the difference between the Female students (as % of total students) in Oman in 1976 and the Female students (as % of total students) in Senegal in 1979?
Your response must be concise. -12.49. What is the difference between the Female students (as % of total students) in India in 1977 and the Female students (as % of total students) in Madagascar in 1978?
Ensure brevity in your answer.  -9.26. What is the difference between the Female students (as % of total students) of India in 1977 and the Female students (as % of total students) of Oman in 1978?
Give a very brief answer. 7.92. What is the difference between the Female students (as % of total students) of India in 1977 and the Female students (as % of total students) of Senegal in 1978?
Your answer should be compact. -1.42. What is the difference between the Female students (as % of total students) in Madagascar in 1977 and the Female students (as % of total students) in Oman in 1978?
Make the answer very short. 14.9. What is the difference between the Female students (as % of total students) of Madagascar in 1977 and the Female students (as % of total students) of Senegal in 1978?
Your answer should be compact. 5.56. What is the difference between the Female students (as % of total students) in Oman in 1977 and the Female students (as % of total students) in Senegal in 1978?
Offer a terse response. -10.93. What is the difference between the Female students (as % of total students) of India in 1977 and the Female students (as % of total students) of Madagascar in 1979?
Your answer should be compact. -8.87. What is the difference between the Female students (as % of total students) of India in 1977 and the Female students (as % of total students) of Oman in 1979?
Provide a short and direct response. 6.15. What is the difference between the Female students (as % of total students) of India in 1977 and the Female students (as % of total students) of Senegal in 1979?
Ensure brevity in your answer.  -1.59. What is the difference between the Female students (as % of total students) in Madagascar in 1977 and the Female students (as % of total students) in Oman in 1979?
Provide a short and direct response. 13.14. What is the difference between the Female students (as % of total students) of Madagascar in 1977 and the Female students (as % of total students) of Senegal in 1979?
Make the answer very short. 5.39. What is the difference between the Female students (as % of total students) of Oman in 1977 and the Female students (as % of total students) of Senegal in 1979?
Provide a succinct answer. -11.1. What is the difference between the Female students (as % of total students) in India in 1978 and the Female students (as % of total students) in Madagascar in 1979?
Keep it short and to the point. -9.25. What is the difference between the Female students (as % of total students) in India in 1978 and the Female students (as % of total students) in Oman in 1979?
Provide a succinct answer. 5.77. What is the difference between the Female students (as % of total students) of India in 1978 and the Female students (as % of total students) of Senegal in 1979?
Your answer should be compact. -1.98. What is the difference between the Female students (as % of total students) in Madagascar in 1978 and the Female students (as % of total students) in Oman in 1979?
Your answer should be compact. 15.42. What is the difference between the Female students (as % of total students) of Madagascar in 1978 and the Female students (as % of total students) of Senegal in 1979?
Your answer should be compact. 7.67. What is the difference between the Female students (as % of total students) of Oman in 1978 and the Female students (as % of total students) of Senegal in 1979?
Make the answer very short. -9.51. What is the average Female students (as % of total students) of India per year?
Your answer should be compact. 37.92. What is the average Female students (as % of total students) in Madagascar per year?
Ensure brevity in your answer.  46.12. What is the average Female students (as % of total students) of Oman per year?
Offer a terse response. 24.38. What is the average Female students (as % of total students) in Senegal per year?
Ensure brevity in your answer.  40.41. In the year 1972, what is the difference between the Female students (as % of total students) of India and Female students (as % of total students) of Madagascar?
Your response must be concise. -8.76. In the year 1972, what is the difference between the Female students (as % of total students) of India and Female students (as % of total students) of Oman?
Give a very brief answer. 24.74. In the year 1972, what is the difference between the Female students (as % of total students) of India and Female students (as % of total students) of Senegal?
Provide a short and direct response. -1.57. In the year 1972, what is the difference between the Female students (as % of total students) of Madagascar and Female students (as % of total students) of Oman?
Offer a very short reply. 33.5. In the year 1972, what is the difference between the Female students (as % of total students) in Madagascar and Female students (as % of total students) in Senegal?
Offer a very short reply. 7.19. In the year 1972, what is the difference between the Female students (as % of total students) in Oman and Female students (as % of total students) in Senegal?
Give a very brief answer. -26.31. In the year 1973, what is the difference between the Female students (as % of total students) in India and Female students (as % of total students) in Madagascar?
Give a very brief answer. -8.68. In the year 1973, what is the difference between the Female students (as % of total students) of India and Female students (as % of total students) of Oman?
Your answer should be compact. 21.11. In the year 1973, what is the difference between the Female students (as % of total students) in India and Female students (as % of total students) in Senegal?
Provide a succinct answer. -1.4. In the year 1973, what is the difference between the Female students (as % of total students) of Madagascar and Female students (as % of total students) of Oman?
Your answer should be very brief. 29.79. In the year 1973, what is the difference between the Female students (as % of total students) in Madagascar and Female students (as % of total students) in Senegal?
Your response must be concise. 7.28. In the year 1973, what is the difference between the Female students (as % of total students) in Oman and Female students (as % of total students) in Senegal?
Give a very brief answer. -22.51. In the year 1974, what is the difference between the Female students (as % of total students) in India and Female students (as % of total students) in Madagascar?
Offer a terse response. -8.47. In the year 1974, what is the difference between the Female students (as % of total students) in India and Female students (as % of total students) in Oman?
Make the answer very short. 15.64. In the year 1974, what is the difference between the Female students (as % of total students) of India and Female students (as % of total students) of Senegal?
Offer a very short reply. -3.98. In the year 1974, what is the difference between the Female students (as % of total students) of Madagascar and Female students (as % of total students) of Oman?
Ensure brevity in your answer.  24.11. In the year 1974, what is the difference between the Female students (as % of total students) in Madagascar and Female students (as % of total students) in Senegal?
Provide a succinct answer. 4.49. In the year 1974, what is the difference between the Female students (as % of total students) in Oman and Female students (as % of total students) in Senegal?
Keep it short and to the point. -19.62. In the year 1975, what is the difference between the Female students (as % of total students) of India and Female students (as % of total students) of Madagascar?
Give a very brief answer. -8.96. In the year 1975, what is the difference between the Female students (as % of total students) of India and Female students (as % of total students) of Oman?
Make the answer very short. 12.7. In the year 1975, what is the difference between the Female students (as % of total students) of India and Female students (as % of total students) of Senegal?
Offer a terse response. -4.23. In the year 1975, what is the difference between the Female students (as % of total students) of Madagascar and Female students (as % of total students) of Oman?
Ensure brevity in your answer.  21.66. In the year 1975, what is the difference between the Female students (as % of total students) of Madagascar and Female students (as % of total students) of Senegal?
Your response must be concise. 4.73. In the year 1975, what is the difference between the Female students (as % of total students) in Oman and Female students (as % of total students) in Senegal?
Give a very brief answer. -16.93. In the year 1976, what is the difference between the Female students (as % of total students) in India and Female students (as % of total students) in Madagascar?
Ensure brevity in your answer.  -5.37. In the year 1976, what is the difference between the Female students (as % of total students) in India and Female students (as % of total students) in Oman?
Your response must be concise. 10.81. In the year 1976, what is the difference between the Female students (as % of total students) in India and Female students (as % of total students) in Senegal?
Offer a terse response. -4.01. In the year 1976, what is the difference between the Female students (as % of total students) of Madagascar and Female students (as % of total students) of Oman?
Provide a short and direct response. 16.17. In the year 1976, what is the difference between the Female students (as % of total students) in Madagascar and Female students (as % of total students) in Senegal?
Your answer should be very brief. 1.36. In the year 1976, what is the difference between the Female students (as % of total students) of Oman and Female students (as % of total students) of Senegal?
Offer a very short reply. -14.81. In the year 1977, what is the difference between the Female students (as % of total students) of India and Female students (as % of total students) of Madagascar?
Offer a very short reply. -6.99. In the year 1977, what is the difference between the Female students (as % of total students) of India and Female students (as % of total students) of Oman?
Ensure brevity in your answer.  9.51. In the year 1977, what is the difference between the Female students (as % of total students) in India and Female students (as % of total students) in Senegal?
Provide a short and direct response. -1.43. In the year 1977, what is the difference between the Female students (as % of total students) in Madagascar and Female students (as % of total students) in Oman?
Keep it short and to the point. 16.49. In the year 1977, what is the difference between the Female students (as % of total students) in Madagascar and Female students (as % of total students) in Senegal?
Make the answer very short. 5.56. In the year 1977, what is the difference between the Female students (as % of total students) in Oman and Female students (as % of total students) in Senegal?
Your response must be concise. -10.93. In the year 1978, what is the difference between the Female students (as % of total students) of India and Female students (as % of total students) of Madagascar?
Provide a succinct answer. -9.65. In the year 1978, what is the difference between the Female students (as % of total students) in India and Female students (as % of total students) in Oman?
Your response must be concise. 7.53. In the year 1978, what is the difference between the Female students (as % of total students) in India and Female students (as % of total students) in Senegal?
Offer a terse response. -1.81. In the year 1978, what is the difference between the Female students (as % of total students) of Madagascar and Female students (as % of total students) of Oman?
Your answer should be compact. 17.18. In the year 1978, what is the difference between the Female students (as % of total students) in Madagascar and Female students (as % of total students) in Senegal?
Keep it short and to the point. 7.84. In the year 1978, what is the difference between the Female students (as % of total students) in Oman and Female students (as % of total students) in Senegal?
Offer a terse response. -9.34. In the year 1979, what is the difference between the Female students (as % of total students) in India and Female students (as % of total students) in Madagascar?
Offer a very short reply. -8.79. In the year 1979, what is the difference between the Female students (as % of total students) of India and Female students (as % of total students) of Oman?
Give a very brief answer. 6.24. In the year 1979, what is the difference between the Female students (as % of total students) of India and Female students (as % of total students) of Senegal?
Your response must be concise. -1.51. In the year 1979, what is the difference between the Female students (as % of total students) of Madagascar and Female students (as % of total students) of Oman?
Make the answer very short. 15.02. In the year 1979, what is the difference between the Female students (as % of total students) of Madagascar and Female students (as % of total students) of Senegal?
Your answer should be compact. 7.28. In the year 1979, what is the difference between the Female students (as % of total students) in Oman and Female students (as % of total students) in Senegal?
Offer a very short reply. -7.75. What is the ratio of the Female students (as % of total students) in Madagascar in 1972 to that in 1973?
Offer a terse response. 0.99. What is the ratio of the Female students (as % of total students) of Oman in 1972 to that in 1973?
Offer a very short reply. 0.76. What is the ratio of the Female students (as % of total students) of Senegal in 1972 to that in 1973?
Offer a terse response. 1. What is the ratio of the Female students (as % of total students) in India in 1972 to that in 1974?
Provide a short and direct response. 0.99. What is the ratio of the Female students (as % of total students) of Oman in 1972 to that in 1974?
Give a very brief answer. 0.57. What is the ratio of the Female students (as % of total students) of Senegal in 1972 to that in 1974?
Ensure brevity in your answer.  0.93. What is the ratio of the Female students (as % of total students) in Madagascar in 1972 to that in 1975?
Provide a succinct answer. 0.99. What is the ratio of the Female students (as % of total students) in Oman in 1972 to that in 1975?
Your response must be concise. 0.5. What is the ratio of the Female students (as % of total students) in Senegal in 1972 to that in 1975?
Provide a short and direct response. 0.93. What is the ratio of the Female students (as % of total students) of India in 1972 to that in 1976?
Ensure brevity in your answer.  0.98. What is the ratio of the Female students (as % of total students) in Madagascar in 1972 to that in 1976?
Ensure brevity in your answer.  1.06. What is the ratio of the Female students (as % of total students) of Oman in 1972 to that in 1976?
Ensure brevity in your answer.  0.47. What is the ratio of the Female students (as % of total students) of Senegal in 1972 to that in 1976?
Offer a terse response. 0.93. What is the ratio of the Female students (as % of total students) of India in 1972 to that in 1977?
Your response must be concise. 0.98. What is the ratio of the Female students (as % of total students) in Madagascar in 1972 to that in 1977?
Keep it short and to the point. 1.02. What is the ratio of the Female students (as % of total students) in Oman in 1972 to that in 1977?
Keep it short and to the point. 0.44. What is the ratio of the Female students (as % of total students) of Senegal in 1972 to that in 1977?
Your response must be concise. 0.99. What is the ratio of the Female students (as % of total students) in Madagascar in 1972 to that in 1978?
Make the answer very short. 0.97. What is the ratio of the Female students (as % of total students) of Oman in 1972 to that in 1978?
Keep it short and to the point. 0.42. What is the ratio of the Female students (as % of total students) of Senegal in 1972 to that in 1978?
Your answer should be compact. 0.99. What is the ratio of the Female students (as % of total students) of India in 1972 to that in 1979?
Give a very brief answer. 0.98. What is the ratio of the Female students (as % of total students) of Madagascar in 1972 to that in 1979?
Your answer should be very brief. 0.98. What is the ratio of the Female students (as % of total students) in Oman in 1972 to that in 1979?
Ensure brevity in your answer.  0.4. What is the ratio of the Female students (as % of total students) of Senegal in 1972 to that in 1979?
Your response must be concise. 0.98. What is the ratio of the Female students (as % of total students) in India in 1973 to that in 1974?
Provide a short and direct response. 1. What is the ratio of the Female students (as % of total students) of Madagascar in 1973 to that in 1974?
Keep it short and to the point. 1. What is the ratio of the Female students (as % of total students) in Oman in 1973 to that in 1974?
Provide a short and direct response. 0.75. What is the ratio of the Female students (as % of total students) in Senegal in 1973 to that in 1974?
Provide a succinct answer. 0.94. What is the ratio of the Female students (as % of total students) in India in 1973 to that in 1975?
Ensure brevity in your answer.  1. What is the ratio of the Female students (as % of total students) in Madagascar in 1973 to that in 1975?
Your response must be concise. 0.99. What is the ratio of the Female students (as % of total students) of Oman in 1973 to that in 1975?
Your answer should be very brief. 0.66. What is the ratio of the Female students (as % of total students) of Senegal in 1973 to that in 1975?
Offer a terse response. 0.93. What is the ratio of the Female students (as % of total students) in Madagascar in 1973 to that in 1976?
Your answer should be very brief. 1.07. What is the ratio of the Female students (as % of total students) of Oman in 1973 to that in 1976?
Offer a terse response. 0.61. What is the ratio of the Female students (as % of total students) in Senegal in 1973 to that in 1976?
Make the answer very short. 0.93. What is the ratio of the Female students (as % of total students) of Madagascar in 1973 to that in 1977?
Keep it short and to the point. 1.03. What is the ratio of the Female students (as % of total students) in Oman in 1973 to that in 1977?
Give a very brief answer. 0.58. What is the ratio of the Female students (as % of total students) of Madagascar in 1973 to that in 1978?
Your response must be concise. 0.98. What is the ratio of the Female students (as % of total students) in Oman in 1973 to that in 1978?
Your response must be concise. 0.55. What is the ratio of the Female students (as % of total students) of Senegal in 1973 to that in 1978?
Offer a very short reply. 0.99. What is the ratio of the Female students (as % of total students) in India in 1973 to that in 1979?
Your answer should be very brief. 0.99. What is the ratio of the Female students (as % of total students) of Madagascar in 1973 to that in 1979?
Ensure brevity in your answer.  0.99. What is the ratio of the Female students (as % of total students) in Oman in 1973 to that in 1979?
Your response must be concise. 0.52. What is the ratio of the Female students (as % of total students) in Senegal in 1973 to that in 1979?
Offer a terse response. 0.99. What is the ratio of the Female students (as % of total students) in India in 1974 to that in 1975?
Make the answer very short. 1. What is the ratio of the Female students (as % of total students) in Madagascar in 1974 to that in 1975?
Keep it short and to the point. 0.99. What is the ratio of the Female students (as % of total students) in Oman in 1974 to that in 1975?
Your answer should be compact. 0.88. What is the ratio of the Female students (as % of total students) of India in 1974 to that in 1976?
Provide a succinct answer. 0.99. What is the ratio of the Female students (as % of total students) in Madagascar in 1974 to that in 1976?
Make the answer very short. 1.07. What is the ratio of the Female students (as % of total students) of Oman in 1974 to that in 1976?
Your response must be concise. 0.81. What is the ratio of the Female students (as % of total students) in Oman in 1974 to that in 1977?
Your answer should be compact. 0.77. What is the ratio of the Female students (as % of total students) in Senegal in 1974 to that in 1977?
Offer a very short reply. 1.06. What is the ratio of the Female students (as % of total students) of Madagascar in 1974 to that in 1978?
Give a very brief answer. 0.98. What is the ratio of the Female students (as % of total students) of Oman in 1974 to that in 1978?
Offer a very short reply. 0.73. What is the ratio of the Female students (as % of total students) of Senegal in 1974 to that in 1978?
Ensure brevity in your answer.  1.06. What is the ratio of the Female students (as % of total students) of Madagascar in 1974 to that in 1979?
Provide a short and direct response. 0.98. What is the ratio of the Female students (as % of total students) in Oman in 1974 to that in 1979?
Provide a succinct answer. 0.69. What is the ratio of the Female students (as % of total students) in Senegal in 1974 to that in 1979?
Ensure brevity in your answer.  1.05. What is the ratio of the Female students (as % of total students) in India in 1975 to that in 1976?
Ensure brevity in your answer.  1. What is the ratio of the Female students (as % of total students) of Madagascar in 1975 to that in 1976?
Your answer should be very brief. 1.08. What is the ratio of the Female students (as % of total students) in Oman in 1975 to that in 1976?
Make the answer very short. 0.92. What is the ratio of the Female students (as % of total students) in Madagascar in 1975 to that in 1977?
Your answer should be compact. 1.04. What is the ratio of the Female students (as % of total students) of Oman in 1975 to that in 1977?
Offer a terse response. 0.88. What is the ratio of the Female students (as % of total students) in Senegal in 1975 to that in 1977?
Offer a very short reply. 1.06. What is the ratio of the Female students (as % of total students) in Madagascar in 1975 to that in 1978?
Give a very brief answer. 0.99. What is the ratio of the Female students (as % of total students) of Oman in 1975 to that in 1978?
Keep it short and to the point. 0.83. What is the ratio of the Female students (as % of total students) in Senegal in 1975 to that in 1978?
Give a very brief answer. 1.06. What is the ratio of the Female students (as % of total students) of Oman in 1975 to that in 1979?
Keep it short and to the point. 0.79. What is the ratio of the Female students (as % of total students) in Senegal in 1975 to that in 1979?
Offer a very short reply. 1.06. What is the ratio of the Female students (as % of total students) in Madagascar in 1976 to that in 1977?
Offer a very short reply. 0.96. What is the ratio of the Female students (as % of total students) of Oman in 1976 to that in 1977?
Provide a short and direct response. 0.95. What is the ratio of the Female students (as % of total students) in Senegal in 1976 to that in 1977?
Your answer should be compact. 1.06. What is the ratio of the Female students (as % of total students) in India in 1976 to that in 1978?
Make the answer very short. 1.01. What is the ratio of the Female students (as % of total students) of Madagascar in 1976 to that in 1978?
Provide a succinct answer. 0.92. What is the ratio of the Female students (as % of total students) of Oman in 1976 to that in 1978?
Provide a succinct answer. 0.9. What is the ratio of the Female students (as % of total students) in Senegal in 1976 to that in 1978?
Your answer should be compact. 1.06. What is the ratio of the Female students (as % of total students) in India in 1976 to that in 1979?
Make the answer very short. 1. What is the ratio of the Female students (as % of total students) in Madagascar in 1976 to that in 1979?
Your answer should be compact. 0.92. What is the ratio of the Female students (as % of total students) of Oman in 1976 to that in 1979?
Ensure brevity in your answer.  0.85. What is the ratio of the Female students (as % of total students) of Senegal in 1976 to that in 1979?
Your response must be concise. 1.06. What is the ratio of the Female students (as % of total students) in India in 1977 to that in 1978?
Your answer should be compact. 1.01. What is the ratio of the Female students (as % of total students) of Madagascar in 1977 to that in 1978?
Provide a short and direct response. 0.95. What is the ratio of the Female students (as % of total students) in Oman in 1977 to that in 1978?
Your answer should be compact. 0.95. What is the ratio of the Female students (as % of total students) of Senegal in 1977 to that in 1978?
Your response must be concise. 1. What is the ratio of the Female students (as % of total students) of Madagascar in 1977 to that in 1979?
Offer a terse response. 0.96. What is the ratio of the Female students (as % of total students) of Oman in 1977 to that in 1979?
Give a very brief answer. 0.9. What is the ratio of the Female students (as % of total students) in Madagascar in 1978 to that in 1979?
Your answer should be compact. 1.01. What is the ratio of the Female students (as % of total students) of Oman in 1978 to that in 1979?
Offer a very short reply. 0.94. What is the difference between the highest and the second highest Female students (as % of total students) in India?
Keep it short and to the point. 0.08. What is the difference between the highest and the second highest Female students (as % of total students) of Madagascar?
Offer a very short reply. 0.39. What is the difference between the highest and the second highest Female students (as % of total students) in Oman?
Ensure brevity in your answer.  1.76. What is the difference between the highest and the second highest Female students (as % of total students) of Senegal?
Your answer should be compact. 0.04. What is the difference between the highest and the lowest Female students (as % of total students) in India?
Make the answer very short. 0.81. What is the difference between the highest and the lowest Female students (as % of total students) of Madagascar?
Ensure brevity in your answer.  3.99. What is the difference between the highest and the lowest Female students (as % of total students) of Oman?
Offer a terse response. 19.31. What is the difference between the highest and the lowest Female students (as % of total students) of Senegal?
Provide a short and direct response. 3.11. 